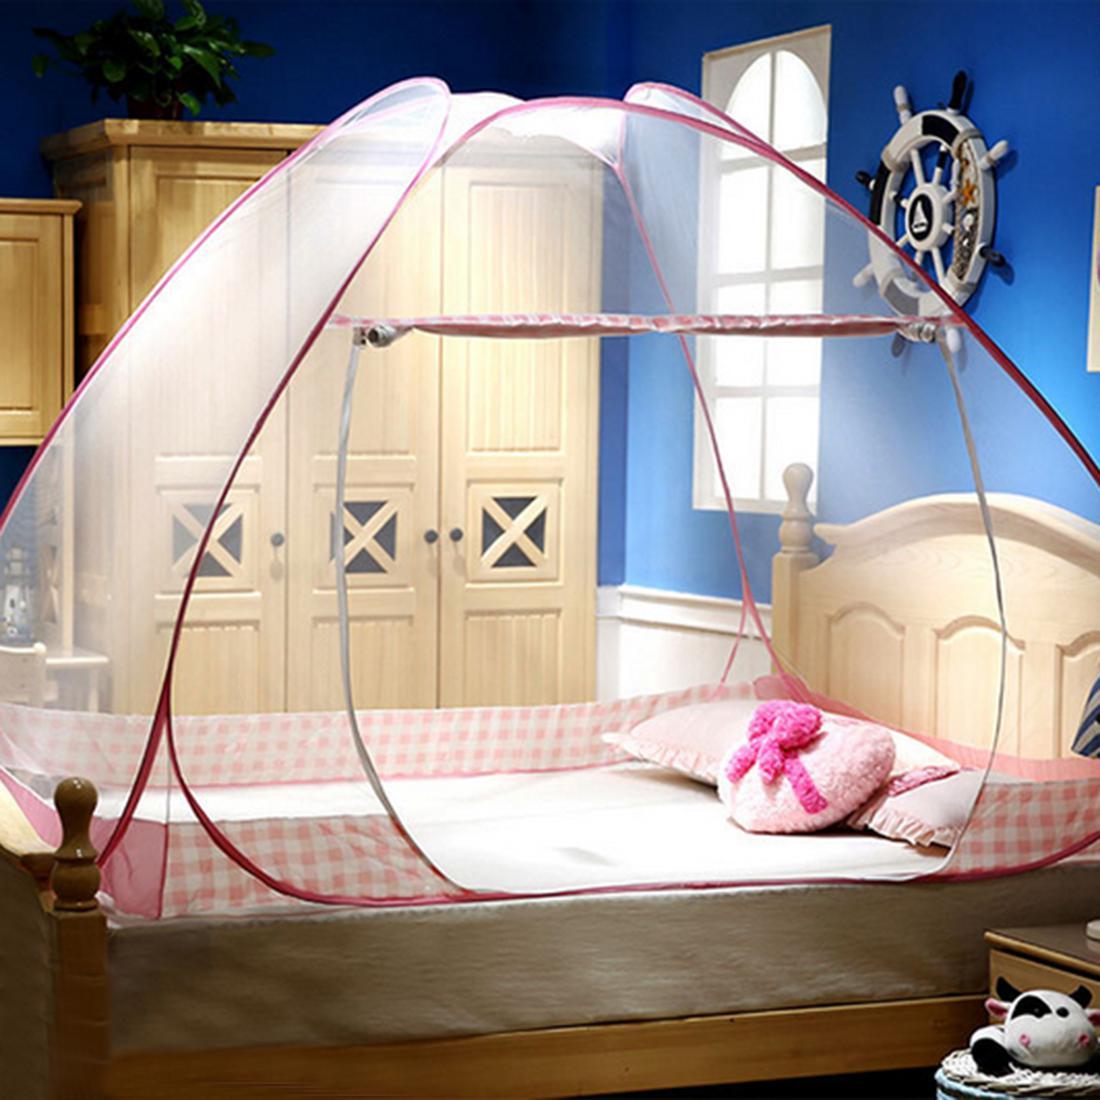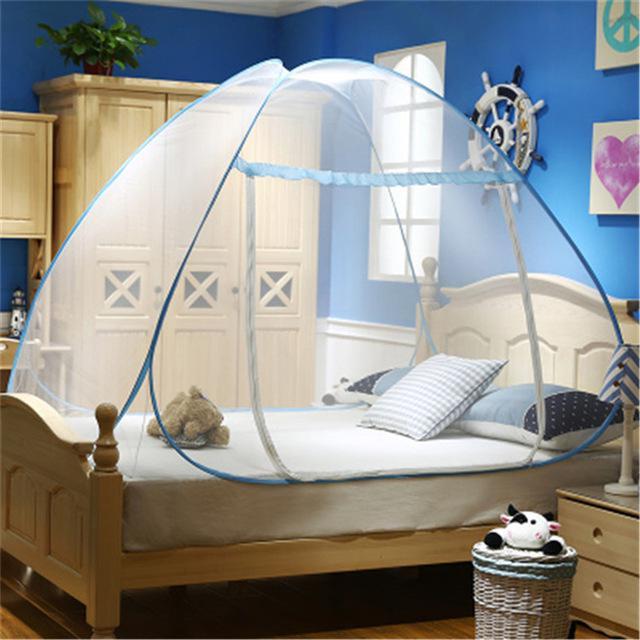The first image is the image on the left, the second image is the image on the right. Given the left and right images, does the statement "One image shows a dome canopy on top of a bed, and the other image features a sheer, blue trimmed canopy that ties like a curtain on at least one side of a bed." hold true? Answer yes or no. No. The first image is the image on the left, the second image is the image on the right. Assess this claim about the two images: "The left and right image contains the same number of tented canopies.". Correct or not? Answer yes or no. Yes. 